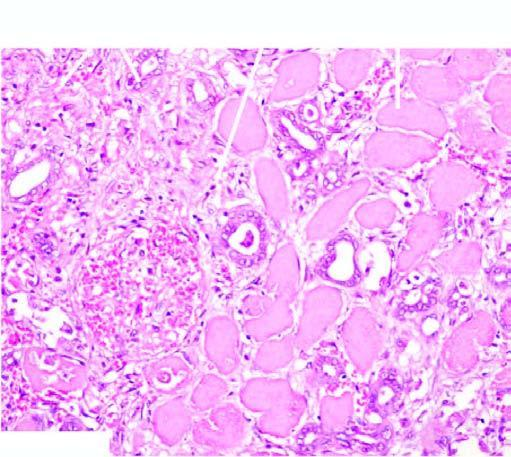what is there at the periphery of the infarct?
Answer the question using a single word or phrase. Acute inflammatory 